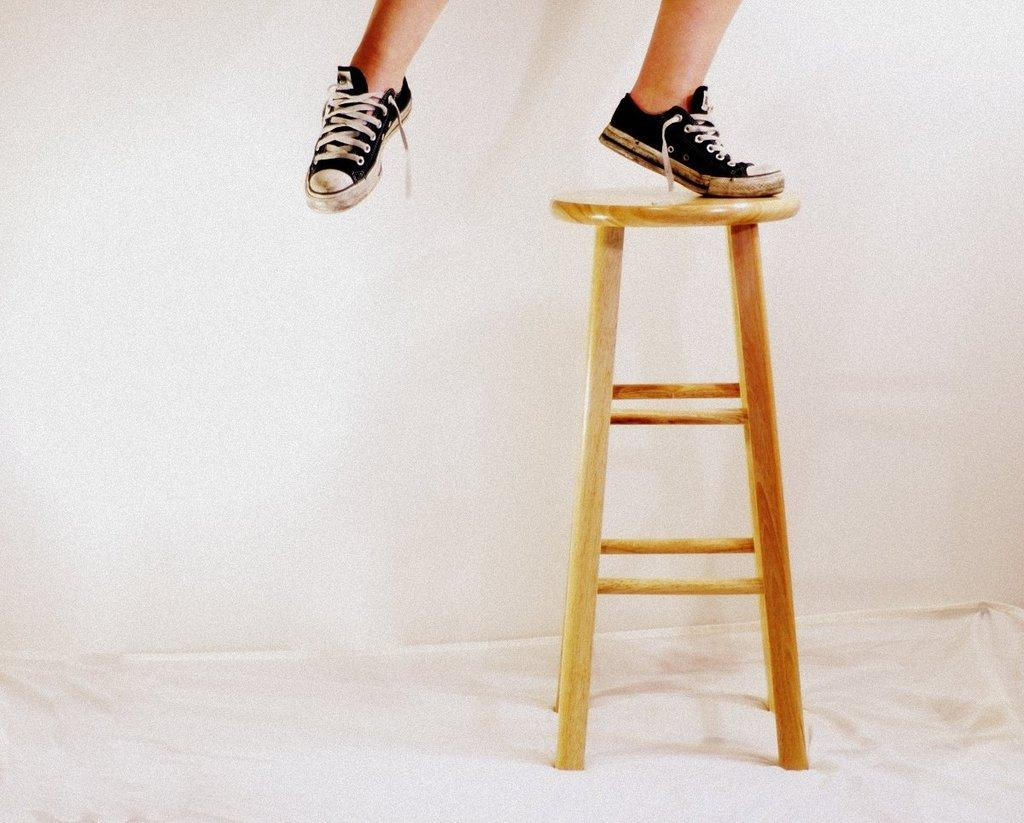What is the main subject of the image? There is a person in the image. What is the person doing in the image? The person is standing on a stool. What type of footwear is the person wearing? The person is wearing shoes. Can you provide an example of an icicle hanging from the person's fang in the image? There is no icicle or fang present in the image; the person is simply standing on a stool while wearing shoes. 